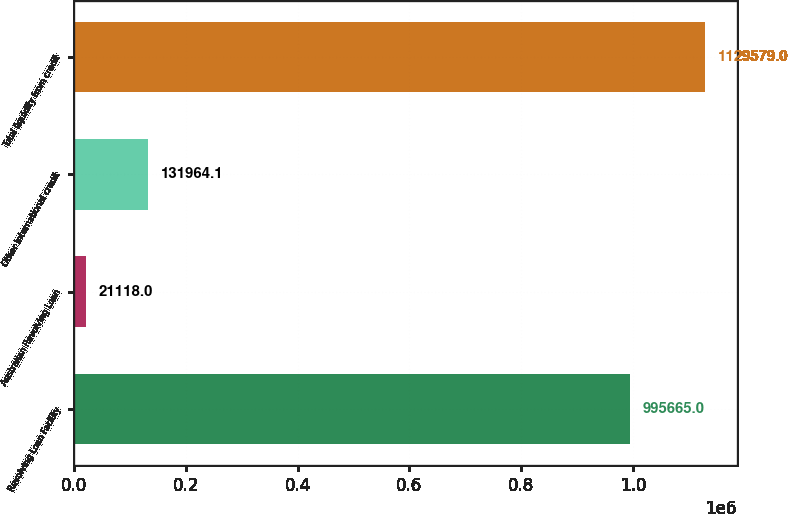Convert chart. <chart><loc_0><loc_0><loc_500><loc_500><bar_chart><fcel>Revolving Loan Facility<fcel>Australian Revolving Loan<fcel>Other international credit<fcel>Total liquidity from credit<nl><fcel>995665<fcel>21118<fcel>131964<fcel>1.12958e+06<nl></chart> 